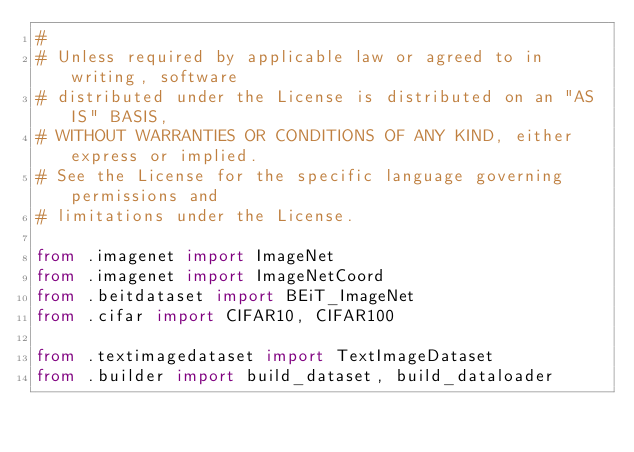Convert code to text. <code><loc_0><loc_0><loc_500><loc_500><_Python_>#
# Unless required by applicable law or agreed to in writing, software
# distributed under the License is distributed on an "AS IS" BASIS,
# WITHOUT WARRANTIES OR CONDITIONS OF ANY KIND, either express or implied.
# See the License for the specific language governing permissions and
# limitations under the License.

from .imagenet import ImageNet
from .imagenet import ImageNetCoord
from .beitdataset import BEiT_ImageNet
from .cifar import CIFAR10, CIFAR100

from .textimagedataset import TextImageDataset
from .builder import build_dataset, build_dataloader
</code> 